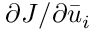<formula> <loc_0><loc_0><loc_500><loc_500>\partial J / \partial { { \bar { u } } _ { i } }</formula> 